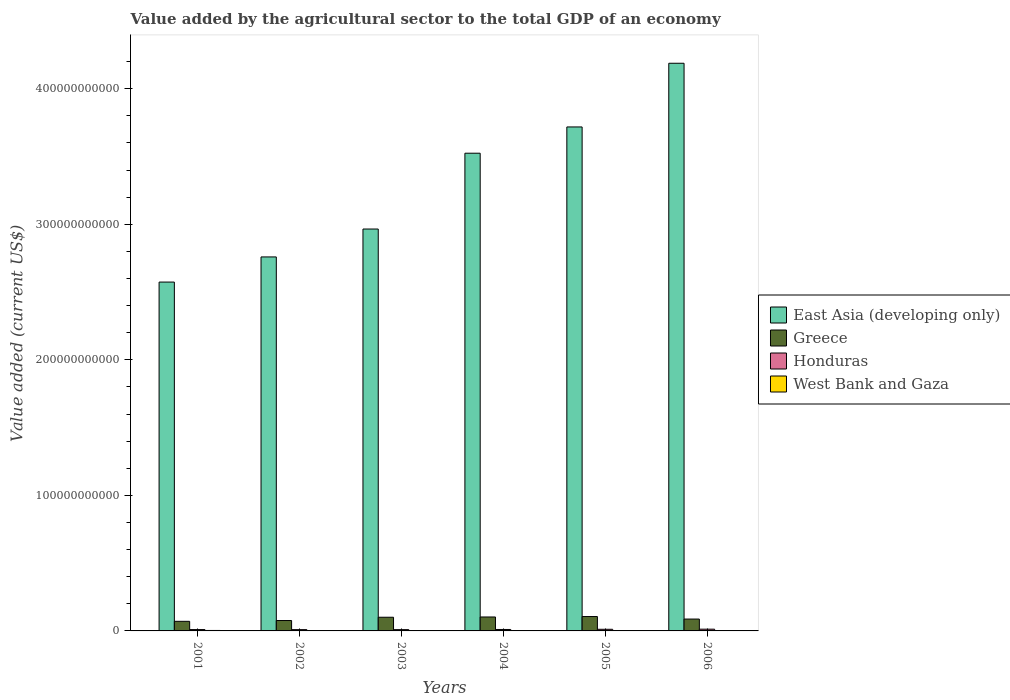How many different coloured bars are there?
Ensure brevity in your answer.  4. Are the number of bars on each tick of the X-axis equal?
Give a very brief answer. Yes. How many bars are there on the 6th tick from the left?
Give a very brief answer. 4. In how many cases, is the number of bars for a given year not equal to the number of legend labels?
Your answer should be very brief. 0. What is the value added by the agricultural sector to the total GDP in West Bank and Gaza in 2003?
Keep it short and to the point. 2.76e+08. Across all years, what is the maximum value added by the agricultural sector to the total GDP in West Bank and Gaza?
Your answer should be compact. 3.40e+08. Across all years, what is the minimum value added by the agricultural sector to the total GDP in Greece?
Give a very brief answer. 7.09e+09. In which year was the value added by the agricultural sector to the total GDP in East Asia (developing only) maximum?
Offer a terse response. 2006. In which year was the value added by the agricultural sector to the total GDP in West Bank and Gaza minimum?
Your answer should be very brief. 2005. What is the total value added by the agricultural sector to the total GDP in West Bank and Gaza in the graph?
Make the answer very short. 1.72e+09. What is the difference between the value added by the agricultural sector to the total GDP in East Asia (developing only) in 2005 and that in 2006?
Give a very brief answer. -4.70e+1. What is the difference between the value added by the agricultural sector to the total GDP in Honduras in 2003 and the value added by the agricultural sector to the total GDP in East Asia (developing only) in 2006?
Give a very brief answer. -4.18e+11. What is the average value added by the agricultural sector to the total GDP in East Asia (developing only) per year?
Keep it short and to the point. 3.29e+11. In the year 2005, what is the difference between the value added by the agricultural sector to the total GDP in Honduras and value added by the agricultural sector to the total GDP in Greece?
Offer a terse response. -9.41e+09. What is the ratio of the value added by the agricultural sector to the total GDP in Greece in 2002 to that in 2003?
Provide a succinct answer. 0.76. Is the value added by the agricultural sector to the total GDP in East Asia (developing only) in 2001 less than that in 2003?
Offer a very short reply. Yes. Is the difference between the value added by the agricultural sector to the total GDP in Honduras in 2002 and 2005 greater than the difference between the value added by the agricultural sector to the total GDP in Greece in 2002 and 2005?
Offer a very short reply. Yes. What is the difference between the highest and the second highest value added by the agricultural sector to the total GDP in East Asia (developing only)?
Provide a short and direct response. 4.70e+1. What is the difference between the highest and the lowest value added by the agricultural sector to the total GDP in West Bank and Gaza?
Provide a short and direct response. 8.61e+07. In how many years, is the value added by the agricultural sector to the total GDP in Greece greater than the average value added by the agricultural sector to the total GDP in Greece taken over all years?
Your answer should be compact. 3. Is it the case that in every year, the sum of the value added by the agricultural sector to the total GDP in West Bank and Gaza and value added by the agricultural sector to the total GDP in East Asia (developing only) is greater than the sum of value added by the agricultural sector to the total GDP in Honduras and value added by the agricultural sector to the total GDP in Greece?
Your response must be concise. Yes. Are all the bars in the graph horizontal?
Ensure brevity in your answer.  No. What is the difference between two consecutive major ticks on the Y-axis?
Offer a very short reply. 1.00e+11. Are the values on the major ticks of Y-axis written in scientific E-notation?
Give a very brief answer. No. Does the graph contain grids?
Provide a succinct answer. No. Where does the legend appear in the graph?
Your response must be concise. Center right. How are the legend labels stacked?
Ensure brevity in your answer.  Vertical. What is the title of the graph?
Ensure brevity in your answer.  Value added by the agricultural sector to the total GDP of an economy. Does "Lesotho" appear as one of the legend labels in the graph?
Offer a very short reply. No. What is the label or title of the X-axis?
Make the answer very short. Years. What is the label or title of the Y-axis?
Provide a succinct answer. Value added (current US$). What is the Value added (current US$) in East Asia (developing only) in 2001?
Make the answer very short. 2.57e+11. What is the Value added (current US$) of Greece in 2001?
Ensure brevity in your answer.  7.09e+09. What is the Value added (current US$) in Honduras in 2001?
Provide a succinct answer. 9.96e+08. What is the Value added (current US$) in West Bank and Gaza in 2001?
Your answer should be very brief. 3.40e+08. What is the Value added (current US$) in East Asia (developing only) in 2002?
Make the answer very short. 2.76e+11. What is the Value added (current US$) in Greece in 2002?
Offer a terse response. 7.67e+09. What is the Value added (current US$) of Honduras in 2002?
Provide a succinct answer. 9.47e+08. What is the Value added (current US$) in West Bank and Gaza in 2002?
Keep it short and to the point. 2.86e+08. What is the Value added (current US$) in East Asia (developing only) in 2003?
Give a very brief answer. 2.97e+11. What is the Value added (current US$) of Greece in 2003?
Provide a short and direct response. 1.01e+1. What is the Value added (current US$) of Honduras in 2003?
Keep it short and to the point. 9.45e+08. What is the Value added (current US$) of West Bank and Gaza in 2003?
Provide a short and direct response. 2.76e+08. What is the Value added (current US$) of East Asia (developing only) in 2004?
Provide a succinct answer. 3.52e+11. What is the Value added (current US$) in Greece in 2004?
Ensure brevity in your answer.  1.03e+1. What is the Value added (current US$) of Honduras in 2004?
Your answer should be very brief. 1.07e+09. What is the Value added (current US$) in West Bank and Gaza in 2004?
Make the answer very short. 3.00e+08. What is the Value added (current US$) of East Asia (developing only) in 2005?
Give a very brief answer. 3.72e+11. What is the Value added (current US$) of Greece in 2005?
Provide a succinct answer. 1.06e+1. What is the Value added (current US$) of Honduras in 2005?
Give a very brief answer. 1.21e+09. What is the Value added (current US$) in West Bank and Gaza in 2005?
Offer a terse response. 2.53e+08. What is the Value added (current US$) in East Asia (developing only) in 2006?
Give a very brief answer. 4.19e+11. What is the Value added (current US$) of Greece in 2006?
Ensure brevity in your answer.  8.75e+09. What is the Value added (current US$) in Honduras in 2006?
Your response must be concise. 1.29e+09. What is the Value added (current US$) of West Bank and Gaza in 2006?
Provide a short and direct response. 2.68e+08. Across all years, what is the maximum Value added (current US$) in East Asia (developing only)?
Your response must be concise. 4.19e+11. Across all years, what is the maximum Value added (current US$) in Greece?
Provide a succinct answer. 1.06e+1. Across all years, what is the maximum Value added (current US$) of Honduras?
Offer a terse response. 1.29e+09. Across all years, what is the maximum Value added (current US$) in West Bank and Gaza?
Offer a very short reply. 3.40e+08. Across all years, what is the minimum Value added (current US$) in East Asia (developing only)?
Provide a succinct answer. 2.57e+11. Across all years, what is the minimum Value added (current US$) of Greece?
Offer a very short reply. 7.09e+09. Across all years, what is the minimum Value added (current US$) in Honduras?
Your answer should be compact. 9.45e+08. Across all years, what is the minimum Value added (current US$) of West Bank and Gaza?
Offer a terse response. 2.53e+08. What is the total Value added (current US$) in East Asia (developing only) in the graph?
Ensure brevity in your answer.  1.97e+12. What is the total Value added (current US$) in Greece in the graph?
Give a very brief answer. 5.45e+1. What is the total Value added (current US$) in Honduras in the graph?
Keep it short and to the point. 6.45e+09. What is the total Value added (current US$) of West Bank and Gaza in the graph?
Ensure brevity in your answer.  1.72e+09. What is the difference between the Value added (current US$) in East Asia (developing only) in 2001 and that in 2002?
Ensure brevity in your answer.  -1.86e+1. What is the difference between the Value added (current US$) of Greece in 2001 and that in 2002?
Provide a short and direct response. -5.86e+08. What is the difference between the Value added (current US$) in Honduras in 2001 and that in 2002?
Your response must be concise. 4.88e+07. What is the difference between the Value added (current US$) of West Bank and Gaza in 2001 and that in 2002?
Ensure brevity in your answer.  5.38e+07. What is the difference between the Value added (current US$) of East Asia (developing only) in 2001 and that in 2003?
Your response must be concise. -3.91e+1. What is the difference between the Value added (current US$) in Greece in 2001 and that in 2003?
Make the answer very short. -3.01e+09. What is the difference between the Value added (current US$) of Honduras in 2001 and that in 2003?
Make the answer very short. 5.08e+07. What is the difference between the Value added (current US$) of West Bank and Gaza in 2001 and that in 2003?
Your response must be concise. 6.32e+07. What is the difference between the Value added (current US$) of East Asia (developing only) in 2001 and that in 2004?
Offer a very short reply. -9.51e+1. What is the difference between the Value added (current US$) in Greece in 2001 and that in 2004?
Your response must be concise. -3.20e+09. What is the difference between the Value added (current US$) of Honduras in 2001 and that in 2004?
Your answer should be compact. -7.14e+07. What is the difference between the Value added (current US$) in West Bank and Gaza in 2001 and that in 2004?
Your response must be concise. 3.97e+07. What is the difference between the Value added (current US$) in East Asia (developing only) in 2001 and that in 2005?
Your response must be concise. -1.14e+11. What is the difference between the Value added (current US$) in Greece in 2001 and that in 2005?
Ensure brevity in your answer.  -3.53e+09. What is the difference between the Value added (current US$) of Honduras in 2001 and that in 2005?
Keep it short and to the point. -2.10e+08. What is the difference between the Value added (current US$) in West Bank and Gaza in 2001 and that in 2005?
Offer a terse response. 8.61e+07. What is the difference between the Value added (current US$) in East Asia (developing only) in 2001 and that in 2006?
Your answer should be very brief. -1.61e+11. What is the difference between the Value added (current US$) in Greece in 2001 and that in 2006?
Offer a terse response. -1.66e+09. What is the difference between the Value added (current US$) of Honduras in 2001 and that in 2006?
Give a very brief answer. -2.89e+08. What is the difference between the Value added (current US$) of West Bank and Gaza in 2001 and that in 2006?
Ensure brevity in your answer.  7.17e+07. What is the difference between the Value added (current US$) of East Asia (developing only) in 2002 and that in 2003?
Ensure brevity in your answer.  -2.06e+1. What is the difference between the Value added (current US$) in Greece in 2002 and that in 2003?
Provide a short and direct response. -2.42e+09. What is the difference between the Value added (current US$) in Honduras in 2002 and that in 2003?
Your response must be concise. 2.02e+06. What is the difference between the Value added (current US$) in West Bank and Gaza in 2002 and that in 2003?
Give a very brief answer. 9.34e+06. What is the difference between the Value added (current US$) of East Asia (developing only) in 2002 and that in 2004?
Offer a terse response. -7.65e+1. What is the difference between the Value added (current US$) of Greece in 2002 and that in 2004?
Provide a succinct answer. -2.61e+09. What is the difference between the Value added (current US$) of Honduras in 2002 and that in 2004?
Keep it short and to the point. -1.20e+08. What is the difference between the Value added (current US$) of West Bank and Gaza in 2002 and that in 2004?
Give a very brief answer. -1.41e+07. What is the difference between the Value added (current US$) in East Asia (developing only) in 2002 and that in 2005?
Ensure brevity in your answer.  -9.59e+1. What is the difference between the Value added (current US$) in Greece in 2002 and that in 2005?
Give a very brief answer. -2.94e+09. What is the difference between the Value added (current US$) in Honduras in 2002 and that in 2005?
Your answer should be very brief. -2.59e+08. What is the difference between the Value added (current US$) of West Bank and Gaza in 2002 and that in 2005?
Offer a terse response. 3.23e+07. What is the difference between the Value added (current US$) of East Asia (developing only) in 2002 and that in 2006?
Your response must be concise. -1.43e+11. What is the difference between the Value added (current US$) of Greece in 2002 and that in 2006?
Make the answer very short. -1.08e+09. What is the difference between the Value added (current US$) of Honduras in 2002 and that in 2006?
Your response must be concise. -3.38e+08. What is the difference between the Value added (current US$) of West Bank and Gaza in 2002 and that in 2006?
Provide a succinct answer. 1.79e+07. What is the difference between the Value added (current US$) of East Asia (developing only) in 2003 and that in 2004?
Provide a short and direct response. -5.59e+1. What is the difference between the Value added (current US$) in Greece in 2003 and that in 2004?
Keep it short and to the point. -1.87e+08. What is the difference between the Value added (current US$) of Honduras in 2003 and that in 2004?
Provide a short and direct response. -1.22e+08. What is the difference between the Value added (current US$) in West Bank and Gaza in 2003 and that in 2004?
Your response must be concise. -2.35e+07. What is the difference between the Value added (current US$) of East Asia (developing only) in 2003 and that in 2005?
Give a very brief answer. -7.53e+1. What is the difference between the Value added (current US$) in Greece in 2003 and that in 2005?
Offer a terse response. -5.20e+08. What is the difference between the Value added (current US$) of Honduras in 2003 and that in 2005?
Offer a very short reply. -2.61e+08. What is the difference between the Value added (current US$) in West Bank and Gaza in 2003 and that in 2005?
Your answer should be compact. 2.30e+07. What is the difference between the Value added (current US$) in East Asia (developing only) in 2003 and that in 2006?
Your response must be concise. -1.22e+11. What is the difference between the Value added (current US$) in Greece in 2003 and that in 2006?
Ensure brevity in your answer.  1.35e+09. What is the difference between the Value added (current US$) in Honduras in 2003 and that in 2006?
Provide a short and direct response. -3.40e+08. What is the difference between the Value added (current US$) of West Bank and Gaza in 2003 and that in 2006?
Offer a terse response. 8.54e+06. What is the difference between the Value added (current US$) in East Asia (developing only) in 2004 and that in 2005?
Your response must be concise. -1.94e+1. What is the difference between the Value added (current US$) in Greece in 2004 and that in 2005?
Ensure brevity in your answer.  -3.32e+08. What is the difference between the Value added (current US$) in Honduras in 2004 and that in 2005?
Provide a short and direct response. -1.39e+08. What is the difference between the Value added (current US$) of West Bank and Gaza in 2004 and that in 2005?
Ensure brevity in your answer.  4.64e+07. What is the difference between the Value added (current US$) of East Asia (developing only) in 2004 and that in 2006?
Offer a very short reply. -6.64e+1. What is the difference between the Value added (current US$) of Greece in 2004 and that in 2006?
Your answer should be very brief. 1.53e+09. What is the difference between the Value added (current US$) of Honduras in 2004 and that in 2006?
Provide a succinct answer. -2.18e+08. What is the difference between the Value added (current US$) in West Bank and Gaza in 2004 and that in 2006?
Offer a terse response. 3.20e+07. What is the difference between the Value added (current US$) in East Asia (developing only) in 2005 and that in 2006?
Offer a terse response. -4.70e+1. What is the difference between the Value added (current US$) in Greece in 2005 and that in 2006?
Your answer should be very brief. 1.87e+09. What is the difference between the Value added (current US$) in Honduras in 2005 and that in 2006?
Your answer should be very brief. -7.93e+07. What is the difference between the Value added (current US$) of West Bank and Gaza in 2005 and that in 2006?
Keep it short and to the point. -1.44e+07. What is the difference between the Value added (current US$) of East Asia (developing only) in 2001 and the Value added (current US$) of Greece in 2002?
Offer a very short reply. 2.50e+11. What is the difference between the Value added (current US$) of East Asia (developing only) in 2001 and the Value added (current US$) of Honduras in 2002?
Make the answer very short. 2.56e+11. What is the difference between the Value added (current US$) of East Asia (developing only) in 2001 and the Value added (current US$) of West Bank and Gaza in 2002?
Your response must be concise. 2.57e+11. What is the difference between the Value added (current US$) of Greece in 2001 and the Value added (current US$) of Honduras in 2002?
Your answer should be very brief. 6.14e+09. What is the difference between the Value added (current US$) of Greece in 2001 and the Value added (current US$) of West Bank and Gaza in 2002?
Offer a terse response. 6.80e+09. What is the difference between the Value added (current US$) of Honduras in 2001 and the Value added (current US$) of West Bank and Gaza in 2002?
Provide a short and direct response. 7.10e+08. What is the difference between the Value added (current US$) of East Asia (developing only) in 2001 and the Value added (current US$) of Greece in 2003?
Your response must be concise. 2.47e+11. What is the difference between the Value added (current US$) in East Asia (developing only) in 2001 and the Value added (current US$) in Honduras in 2003?
Your answer should be compact. 2.56e+11. What is the difference between the Value added (current US$) of East Asia (developing only) in 2001 and the Value added (current US$) of West Bank and Gaza in 2003?
Make the answer very short. 2.57e+11. What is the difference between the Value added (current US$) of Greece in 2001 and the Value added (current US$) of Honduras in 2003?
Make the answer very short. 6.14e+09. What is the difference between the Value added (current US$) of Greece in 2001 and the Value added (current US$) of West Bank and Gaza in 2003?
Provide a short and direct response. 6.81e+09. What is the difference between the Value added (current US$) in Honduras in 2001 and the Value added (current US$) in West Bank and Gaza in 2003?
Provide a short and direct response. 7.20e+08. What is the difference between the Value added (current US$) of East Asia (developing only) in 2001 and the Value added (current US$) of Greece in 2004?
Make the answer very short. 2.47e+11. What is the difference between the Value added (current US$) in East Asia (developing only) in 2001 and the Value added (current US$) in Honduras in 2004?
Your answer should be compact. 2.56e+11. What is the difference between the Value added (current US$) in East Asia (developing only) in 2001 and the Value added (current US$) in West Bank and Gaza in 2004?
Make the answer very short. 2.57e+11. What is the difference between the Value added (current US$) of Greece in 2001 and the Value added (current US$) of Honduras in 2004?
Provide a short and direct response. 6.02e+09. What is the difference between the Value added (current US$) of Greece in 2001 and the Value added (current US$) of West Bank and Gaza in 2004?
Ensure brevity in your answer.  6.79e+09. What is the difference between the Value added (current US$) of Honduras in 2001 and the Value added (current US$) of West Bank and Gaza in 2004?
Offer a terse response. 6.96e+08. What is the difference between the Value added (current US$) in East Asia (developing only) in 2001 and the Value added (current US$) in Greece in 2005?
Make the answer very short. 2.47e+11. What is the difference between the Value added (current US$) in East Asia (developing only) in 2001 and the Value added (current US$) in Honduras in 2005?
Offer a very short reply. 2.56e+11. What is the difference between the Value added (current US$) in East Asia (developing only) in 2001 and the Value added (current US$) in West Bank and Gaza in 2005?
Keep it short and to the point. 2.57e+11. What is the difference between the Value added (current US$) in Greece in 2001 and the Value added (current US$) in Honduras in 2005?
Offer a very short reply. 5.88e+09. What is the difference between the Value added (current US$) in Greece in 2001 and the Value added (current US$) in West Bank and Gaza in 2005?
Your response must be concise. 6.83e+09. What is the difference between the Value added (current US$) of Honduras in 2001 and the Value added (current US$) of West Bank and Gaza in 2005?
Offer a terse response. 7.43e+08. What is the difference between the Value added (current US$) of East Asia (developing only) in 2001 and the Value added (current US$) of Greece in 2006?
Ensure brevity in your answer.  2.49e+11. What is the difference between the Value added (current US$) of East Asia (developing only) in 2001 and the Value added (current US$) of Honduras in 2006?
Provide a succinct answer. 2.56e+11. What is the difference between the Value added (current US$) in East Asia (developing only) in 2001 and the Value added (current US$) in West Bank and Gaza in 2006?
Provide a short and direct response. 2.57e+11. What is the difference between the Value added (current US$) in Greece in 2001 and the Value added (current US$) in Honduras in 2006?
Your answer should be compact. 5.80e+09. What is the difference between the Value added (current US$) in Greece in 2001 and the Value added (current US$) in West Bank and Gaza in 2006?
Provide a succinct answer. 6.82e+09. What is the difference between the Value added (current US$) in Honduras in 2001 and the Value added (current US$) in West Bank and Gaza in 2006?
Ensure brevity in your answer.  7.28e+08. What is the difference between the Value added (current US$) of East Asia (developing only) in 2002 and the Value added (current US$) of Greece in 2003?
Keep it short and to the point. 2.66e+11. What is the difference between the Value added (current US$) in East Asia (developing only) in 2002 and the Value added (current US$) in Honduras in 2003?
Your response must be concise. 2.75e+11. What is the difference between the Value added (current US$) of East Asia (developing only) in 2002 and the Value added (current US$) of West Bank and Gaza in 2003?
Your answer should be compact. 2.76e+11. What is the difference between the Value added (current US$) in Greece in 2002 and the Value added (current US$) in Honduras in 2003?
Make the answer very short. 6.73e+09. What is the difference between the Value added (current US$) of Greece in 2002 and the Value added (current US$) of West Bank and Gaza in 2003?
Provide a succinct answer. 7.40e+09. What is the difference between the Value added (current US$) in Honduras in 2002 and the Value added (current US$) in West Bank and Gaza in 2003?
Your answer should be compact. 6.71e+08. What is the difference between the Value added (current US$) of East Asia (developing only) in 2002 and the Value added (current US$) of Greece in 2004?
Make the answer very short. 2.66e+11. What is the difference between the Value added (current US$) in East Asia (developing only) in 2002 and the Value added (current US$) in Honduras in 2004?
Offer a terse response. 2.75e+11. What is the difference between the Value added (current US$) of East Asia (developing only) in 2002 and the Value added (current US$) of West Bank and Gaza in 2004?
Provide a succinct answer. 2.76e+11. What is the difference between the Value added (current US$) of Greece in 2002 and the Value added (current US$) of Honduras in 2004?
Provide a succinct answer. 6.60e+09. What is the difference between the Value added (current US$) in Greece in 2002 and the Value added (current US$) in West Bank and Gaza in 2004?
Offer a terse response. 7.37e+09. What is the difference between the Value added (current US$) in Honduras in 2002 and the Value added (current US$) in West Bank and Gaza in 2004?
Your response must be concise. 6.48e+08. What is the difference between the Value added (current US$) of East Asia (developing only) in 2002 and the Value added (current US$) of Greece in 2005?
Make the answer very short. 2.65e+11. What is the difference between the Value added (current US$) in East Asia (developing only) in 2002 and the Value added (current US$) in Honduras in 2005?
Offer a very short reply. 2.75e+11. What is the difference between the Value added (current US$) of East Asia (developing only) in 2002 and the Value added (current US$) of West Bank and Gaza in 2005?
Provide a succinct answer. 2.76e+11. What is the difference between the Value added (current US$) of Greece in 2002 and the Value added (current US$) of Honduras in 2005?
Offer a very short reply. 6.47e+09. What is the difference between the Value added (current US$) in Greece in 2002 and the Value added (current US$) in West Bank and Gaza in 2005?
Keep it short and to the point. 7.42e+09. What is the difference between the Value added (current US$) in Honduras in 2002 and the Value added (current US$) in West Bank and Gaza in 2005?
Your response must be concise. 6.94e+08. What is the difference between the Value added (current US$) of East Asia (developing only) in 2002 and the Value added (current US$) of Greece in 2006?
Offer a very short reply. 2.67e+11. What is the difference between the Value added (current US$) in East Asia (developing only) in 2002 and the Value added (current US$) in Honduras in 2006?
Your answer should be compact. 2.75e+11. What is the difference between the Value added (current US$) in East Asia (developing only) in 2002 and the Value added (current US$) in West Bank and Gaza in 2006?
Give a very brief answer. 2.76e+11. What is the difference between the Value added (current US$) in Greece in 2002 and the Value added (current US$) in Honduras in 2006?
Make the answer very short. 6.39e+09. What is the difference between the Value added (current US$) of Greece in 2002 and the Value added (current US$) of West Bank and Gaza in 2006?
Provide a succinct answer. 7.40e+09. What is the difference between the Value added (current US$) in Honduras in 2002 and the Value added (current US$) in West Bank and Gaza in 2006?
Provide a short and direct response. 6.80e+08. What is the difference between the Value added (current US$) of East Asia (developing only) in 2003 and the Value added (current US$) of Greece in 2004?
Make the answer very short. 2.86e+11. What is the difference between the Value added (current US$) of East Asia (developing only) in 2003 and the Value added (current US$) of Honduras in 2004?
Give a very brief answer. 2.95e+11. What is the difference between the Value added (current US$) of East Asia (developing only) in 2003 and the Value added (current US$) of West Bank and Gaza in 2004?
Give a very brief answer. 2.96e+11. What is the difference between the Value added (current US$) of Greece in 2003 and the Value added (current US$) of Honduras in 2004?
Your response must be concise. 9.03e+09. What is the difference between the Value added (current US$) in Greece in 2003 and the Value added (current US$) in West Bank and Gaza in 2004?
Keep it short and to the point. 9.80e+09. What is the difference between the Value added (current US$) of Honduras in 2003 and the Value added (current US$) of West Bank and Gaza in 2004?
Your answer should be compact. 6.46e+08. What is the difference between the Value added (current US$) of East Asia (developing only) in 2003 and the Value added (current US$) of Greece in 2005?
Your response must be concise. 2.86e+11. What is the difference between the Value added (current US$) of East Asia (developing only) in 2003 and the Value added (current US$) of Honduras in 2005?
Your answer should be compact. 2.95e+11. What is the difference between the Value added (current US$) of East Asia (developing only) in 2003 and the Value added (current US$) of West Bank and Gaza in 2005?
Give a very brief answer. 2.96e+11. What is the difference between the Value added (current US$) of Greece in 2003 and the Value added (current US$) of Honduras in 2005?
Give a very brief answer. 8.89e+09. What is the difference between the Value added (current US$) in Greece in 2003 and the Value added (current US$) in West Bank and Gaza in 2005?
Give a very brief answer. 9.84e+09. What is the difference between the Value added (current US$) of Honduras in 2003 and the Value added (current US$) of West Bank and Gaza in 2005?
Offer a terse response. 6.92e+08. What is the difference between the Value added (current US$) in East Asia (developing only) in 2003 and the Value added (current US$) in Greece in 2006?
Provide a short and direct response. 2.88e+11. What is the difference between the Value added (current US$) of East Asia (developing only) in 2003 and the Value added (current US$) of Honduras in 2006?
Give a very brief answer. 2.95e+11. What is the difference between the Value added (current US$) of East Asia (developing only) in 2003 and the Value added (current US$) of West Bank and Gaza in 2006?
Keep it short and to the point. 2.96e+11. What is the difference between the Value added (current US$) of Greece in 2003 and the Value added (current US$) of Honduras in 2006?
Ensure brevity in your answer.  8.81e+09. What is the difference between the Value added (current US$) of Greece in 2003 and the Value added (current US$) of West Bank and Gaza in 2006?
Offer a terse response. 9.83e+09. What is the difference between the Value added (current US$) of Honduras in 2003 and the Value added (current US$) of West Bank and Gaza in 2006?
Ensure brevity in your answer.  6.78e+08. What is the difference between the Value added (current US$) of East Asia (developing only) in 2004 and the Value added (current US$) of Greece in 2005?
Ensure brevity in your answer.  3.42e+11. What is the difference between the Value added (current US$) in East Asia (developing only) in 2004 and the Value added (current US$) in Honduras in 2005?
Provide a short and direct response. 3.51e+11. What is the difference between the Value added (current US$) in East Asia (developing only) in 2004 and the Value added (current US$) in West Bank and Gaza in 2005?
Make the answer very short. 3.52e+11. What is the difference between the Value added (current US$) in Greece in 2004 and the Value added (current US$) in Honduras in 2005?
Your answer should be very brief. 9.08e+09. What is the difference between the Value added (current US$) in Greece in 2004 and the Value added (current US$) in West Bank and Gaza in 2005?
Your response must be concise. 1.00e+1. What is the difference between the Value added (current US$) in Honduras in 2004 and the Value added (current US$) in West Bank and Gaza in 2005?
Ensure brevity in your answer.  8.14e+08. What is the difference between the Value added (current US$) in East Asia (developing only) in 2004 and the Value added (current US$) in Greece in 2006?
Provide a short and direct response. 3.44e+11. What is the difference between the Value added (current US$) in East Asia (developing only) in 2004 and the Value added (current US$) in Honduras in 2006?
Keep it short and to the point. 3.51e+11. What is the difference between the Value added (current US$) of East Asia (developing only) in 2004 and the Value added (current US$) of West Bank and Gaza in 2006?
Your response must be concise. 3.52e+11. What is the difference between the Value added (current US$) of Greece in 2004 and the Value added (current US$) of Honduras in 2006?
Offer a terse response. 9.00e+09. What is the difference between the Value added (current US$) in Greece in 2004 and the Value added (current US$) in West Bank and Gaza in 2006?
Provide a succinct answer. 1.00e+1. What is the difference between the Value added (current US$) in Honduras in 2004 and the Value added (current US$) in West Bank and Gaza in 2006?
Your answer should be compact. 8.00e+08. What is the difference between the Value added (current US$) in East Asia (developing only) in 2005 and the Value added (current US$) in Greece in 2006?
Your answer should be compact. 3.63e+11. What is the difference between the Value added (current US$) in East Asia (developing only) in 2005 and the Value added (current US$) in Honduras in 2006?
Give a very brief answer. 3.71e+11. What is the difference between the Value added (current US$) in East Asia (developing only) in 2005 and the Value added (current US$) in West Bank and Gaza in 2006?
Keep it short and to the point. 3.72e+11. What is the difference between the Value added (current US$) of Greece in 2005 and the Value added (current US$) of Honduras in 2006?
Give a very brief answer. 9.33e+09. What is the difference between the Value added (current US$) of Greece in 2005 and the Value added (current US$) of West Bank and Gaza in 2006?
Your answer should be very brief. 1.03e+1. What is the difference between the Value added (current US$) of Honduras in 2005 and the Value added (current US$) of West Bank and Gaza in 2006?
Provide a succinct answer. 9.38e+08. What is the average Value added (current US$) of East Asia (developing only) per year?
Your answer should be compact. 3.29e+11. What is the average Value added (current US$) in Greece per year?
Provide a short and direct response. 9.08e+09. What is the average Value added (current US$) of Honduras per year?
Offer a terse response. 1.07e+09. What is the average Value added (current US$) in West Bank and Gaza per year?
Provide a short and direct response. 2.87e+08. In the year 2001, what is the difference between the Value added (current US$) in East Asia (developing only) and Value added (current US$) in Greece?
Your answer should be very brief. 2.50e+11. In the year 2001, what is the difference between the Value added (current US$) of East Asia (developing only) and Value added (current US$) of Honduras?
Provide a short and direct response. 2.56e+11. In the year 2001, what is the difference between the Value added (current US$) in East Asia (developing only) and Value added (current US$) in West Bank and Gaza?
Offer a terse response. 2.57e+11. In the year 2001, what is the difference between the Value added (current US$) in Greece and Value added (current US$) in Honduras?
Provide a short and direct response. 6.09e+09. In the year 2001, what is the difference between the Value added (current US$) of Greece and Value added (current US$) of West Bank and Gaza?
Ensure brevity in your answer.  6.75e+09. In the year 2001, what is the difference between the Value added (current US$) of Honduras and Value added (current US$) of West Bank and Gaza?
Provide a succinct answer. 6.57e+08. In the year 2002, what is the difference between the Value added (current US$) in East Asia (developing only) and Value added (current US$) in Greece?
Keep it short and to the point. 2.68e+11. In the year 2002, what is the difference between the Value added (current US$) of East Asia (developing only) and Value added (current US$) of Honduras?
Provide a short and direct response. 2.75e+11. In the year 2002, what is the difference between the Value added (current US$) in East Asia (developing only) and Value added (current US$) in West Bank and Gaza?
Ensure brevity in your answer.  2.76e+11. In the year 2002, what is the difference between the Value added (current US$) of Greece and Value added (current US$) of Honduras?
Offer a very short reply. 6.72e+09. In the year 2002, what is the difference between the Value added (current US$) of Greece and Value added (current US$) of West Bank and Gaza?
Offer a very short reply. 7.39e+09. In the year 2002, what is the difference between the Value added (current US$) in Honduras and Value added (current US$) in West Bank and Gaza?
Keep it short and to the point. 6.62e+08. In the year 2003, what is the difference between the Value added (current US$) of East Asia (developing only) and Value added (current US$) of Greece?
Keep it short and to the point. 2.86e+11. In the year 2003, what is the difference between the Value added (current US$) of East Asia (developing only) and Value added (current US$) of Honduras?
Your answer should be compact. 2.96e+11. In the year 2003, what is the difference between the Value added (current US$) of East Asia (developing only) and Value added (current US$) of West Bank and Gaza?
Give a very brief answer. 2.96e+11. In the year 2003, what is the difference between the Value added (current US$) of Greece and Value added (current US$) of Honduras?
Provide a short and direct response. 9.15e+09. In the year 2003, what is the difference between the Value added (current US$) of Greece and Value added (current US$) of West Bank and Gaza?
Your response must be concise. 9.82e+09. In the year 2003, what is the difference between the Value added (current US$) of Honduras and Value added (current US$) of West Bank and Gaza?
Provide a succinct answer. 6.69e+08. In the year 2004, what is the difference between the Value added (current US$) of East Asia (developing only) and Value added (current US$) of Greece?
Your answer should be compact. 3.42e+11. In the year 2004, what is the difference between the Value added (current US$) of East Asia (developing only) and Value added (current US$) of Honduras?
Offer a terse response. 3.51e+11. In the year 2004, what is the difference between the Value added (current US$) of East Asia (developing only) and Value added (current US$) of West Bank and Gaza?
Offer a very short reply. 3.52e+11. In the year 2004, what is the difference between the Value added (current US$) of Greece and Value added (current US$) of Honduras?
Give a very brief answer. 9.22e+09. In the year 2004, what is the difference between the Value added (current US$) of Greece and Value added (current US$) of West Bank and Gaza?
Keep it short and to the point. 9.98e+09. In the year 2004, what is the difference between the Value added (current US$) of Honduras and Value added (current US$) of West Bank and Gaza?
Your answer should be compact. 7.68e+08. In the year 2005, what is the difference between the Value added (current US$) in East Asia (developing only) and Value added (current US$) in Greece?
Your response must be concise. 3.61e+11. In the year 2005, what is the difference between the Value added (current US$) in East Asia (developing only) and Value added (current US$) in Honduras?
Ensure brevity in your answer.  3.71e+11. In the year 2005, what is the difference between the Value added (current US$) in East Asia (developing only) and Value added (current US$) in West Bank and Gaza?
Ensure brevity in your answer.  3.72e+11. In the year 2005, what is the difference between the Value added (current US$) of Greece and Value added (current US$) of Honduras?
Make the answer very short. 9.41e+09. In the year 2005, what is the difference between the Value added (current US$) in Greece and Value added (current US$) in West Bank and Gaza?
Keep it short and to the point. 1.04e+1. In the year 2005, what is the difference between the Value added (current US$) of Honduras and Value added (current US$) of West Bank and Gaza?
Provide a short and direct response. 9.53e+08. In the year 2006, what is the difference between the Value added (current US$) of East Asia (developing only) and Value added (current US$) of Greece?
Give a very brief answer. 4.10e+11. In the year 2006, what is the difference between the Value added (current US$) of East Asia (developing only) and Value added (current US$) of Honduras?
Offer a very short reply. 4.18e+11. In the year 2006, what is the difference between the Value added (current US$) in East Asia (developing only) and Value added (current US$) in West Bank and Gaza?
Offer a very short reply. 4.19e+11. In the year 2006, what is the difference between the Value added (current US$) of Greece and Value added (current US$) of Honduras?
Make the answer very short. 7.46e+09. In the year 2006, what is the difference between the Value added (current US$) of Greece and Value added (current US$) of West Bank and Gaza?
Your response must be concise. 8.48e+09. In the year 2006, what is the difference between the Value added (current US$) of Honduras and Value added (current US$) of West Bank and Gaza?
Ensure brevity in your answer.  1.02e+09. What is the ratio of the Value added (current US$) in East Asia (developing only) in 2001 to that in 2002?
Your answer should be very brief. 0.93. What is the ratio of the Value added (current US$) of Greece in 2001 to that in 2002?
Offer a very short reply. 0.92. What is the ratio of the Value added (current US$) in Honduras in 2001 to that in 2002?
Your answer should be very brief. 1.05. What is the ratio of the Value added (current US$) of West Bank and Gaza in 2001 to that in 2002?
Your answer should be very brief. 1.19. What is the ratio of the Value added (current US$) in East Asia (developing only) in 2001 to that in 2003?
Keep it short and to the point. 0.87. What is the ratio of the Value added (current US$) in Greece in 2001 to that in 2003?
Provide a short and direct response. 0.7. What is the ratio of the Value added (current US$) of Honduras in 2001 to that in 2003?
Keep it short and to the point. 1.05. What is the ratio of the Value added (current US$) of West Bank and Gaza in 2001 to that in 2003?
Provide a short and direct response. 1.23. What is the ratio of the Value added (current US$) in East Asia (developing only) in 2001 to that in 2004?
Your answer should be compact. 0.73. What is the ratio of the Value added (current US$) of Greece in 2001 to that in 2004?
Your response must be concise. 0.69. What is the ratio of the Value added (current US$) in Honduras in 2001 to that in 2004?
Make the answer very short. 0.93. What is the ratio of the Value added (current US$) in West Bank and Gaza in 2001 to that in 2004?
Your answer should be very brief. 1.13. What is the ratio of the Value added (current US$) of East Asia (developing only) in 2001 to that in 2005?
Provide a short and direct response. 0.69. What is the ratio of the Value added (current US$) in Greece in 2001 to that in 2005?
Your response must be concise. 0.67. What is the ratio of the Value added (current US$) in Honduras in 2001 to that in 2005?
Make the answer very short. 0.83. What is the ratio of the Value added (current US$) of West Bank and Gaza in 2001 to that in 2005?
Your answer should be very brief. 1.34. What is the ratio of the Value added (current US$) of East Asia (developing only) in 2001 to that in 2006?
Make the answer very short. 0.61. What is the ratio of the Value added (current US$) in Greece in 2001 to that in 2006?
Provide a succinct answer. 0.81. What is the ratio of the Value added (current US$) of Honduras in 2001 to that in 2006?
Your response must be concise. 0.78. What is the ratio of the Value added (current US$) in West Bank and Gaza in 2001 to that in 2006?
Your response must be concise. 1.27. What is the ratio of the Value added (current US$) of East Asia (developing only) in 2002 to that in 2003?
Keep it short and to the point. 0.93. What is the ratio of the Value added (current US$) in Greece in 2002 to that in 2003?
Your answer should be compact. 0.76. What is the ratio of the Value added (current US$) of Honduras in 2002 to that in 2003?
Your response must be concise. 1. What is the ratio of the Value added (current US$) in West Bank and Gaza in 2002 to that in 2003?
Provide a short and direct response. 1.03. What is the ratio of the Value added (current US$) in East Asia (developing only) in 2002 to that in 2004?
Provide a short and direct response. 0.78. What is the ratio of the Value added (current US$) of Greece in 2002 to that in 2004?
Provide a succinct answer. 0.75. What is the ratio of the Value added (current US$) in Honduras in 2002 to that in 2004?
Offer a terse response. 0.89. What is the ratio of the Value added (current US$) in West Bank and Gaza in 2002 to that in 2004?
Provide a succinct answer. 0.95. What is the ratio of the Value added (current US$) in East Asia (developing only) in 2002 to that in 2005?
Your response must be concise. 0.74. What is the ratio of the Value added (current US$) in Greece in 2002 to that in 2005?
Your response must be concise. 0.72. What is the ratio of the Value added (current US$) of Honduras in 2002 to that in 2005?
Provide a short and direct response. 0.79. What is the ratio of the Value added (current US$) in West Bank and Gaza in 2002 to that in 2005?
Your answer should be very brief. 1.13. What is the ratio of the Value added (current US$) of East Asia (developing only) in 2002 to that in 2006?
Provide a succinct answer. 0.66. What is the ratio of the Value added (current US$) in Greece in 2002 to that in 2006?
Your response must be concise. 0.88. What is the ratio of the Value added (current US$) in Honduras in 2002 to that in 2006?
Offer a terse response. 0.74. What is the ratio of the Value added (current US$) in West Bank and Gaza in 2002 to that in 2006?
Offer a terse response. 1.07. What is the ratio of the Value added (current US$) of East Asia (developing only) in 2003 to that in 2004?
Make the answer very short. 0.84. What is the ratio of the Value added (current US$) in Greece in 2003 to that in 2004?
Your answer should be compact. 0.98. What is the ratio of the Value added (current US$) of Honduras in 2003 to that in 2004?
Your answer should be very brief. 0.89. What is the ratio of the Value added (current US$) of West Bank and Gaza in 2003 to that in 2004?
Give a very brief answer. 0.92. What is the ratio of the Value added (current US$) in East Asia (developing only) in 2003 to that in 2005?
Your answer should be compact. 0.8. What is the ratio of the Value added (current US$) of Greece in 2003 to that in 2005?
Give a very brief answer. 0.95. What is the ratio of the Value added (current US$) of Honduras in 2003 to that in 2005?
Your response must be concise. 0.78. What is the ratio of the Value added (current US$) of West Bank and Gaza in 2003 to that in 2005?
Your answer should be very brief. 1.09. What is the ratio of the Value added (current US$) of East Asia (developing only) in 2003 to that in 2006?
Your answer should be very brief. 0.71. What is the ratio of the Value added (current US$) of Greece in 2003 to that in 2006?
Ensure brevity in your answer.  1.15. What is the ratio of the Value added (current US$) of Honduras in 2003 to that in 2006?
Provide a short and direct response. 0.74. What is the ratio of the Value added (current US$) in West Bank and Gaza in 2003 to that in 2006?
Your response must be concise. 1.03. What is the ratio of the Value added (current US$) of East Asia (developing only) in 2004 to that in 2005?
Keep it short and to the point. 0.95. What is the ratio of the Value added (current US$) of Greece in 2004 to that in 2005?
Give a very brief answer. 0.97. What is the ratio of the Value added (current US$) in Honduras in 2004 to that in 2005?
Ensure brevity in your answer.  0.89. What is the ratio of the Value added (current US$) of West Bank and Gaza in 2004 to that in 2005?
Offer a very short reply. 1.18. What is the ratio of the Value added (current US$) of East Asia (developing only) in 2004 to that in 2006?
Your answer should be very brief. 0.84. What is the ratio of the Value added (current US$) of Greece in 2004 to that in 2006?
Give a very brief answer. 1.18. What is the ratio of the Value added (current US$) in Honduras in 2004 to that in 2006?
Your answer should be very brief. 0.83. What is the ratio of the Value added (current US$) of West Bank and Gaza in 2004 to that in 2006?
Ensure brevity in your answer.  1.12. What is the ratio of the Value added (current US$) of East Asia (developing only) in 2005 to that in 2006?
Ensure brevity in your answer.  0.89. What is the ratio of the Value added (current US$) in Greece in 2005 to that in 2006?
Provide a short and direct response. 1.21. What is the ratio of the Value added (current US$) of Honduras in 2005 to that in 2006?
Keep it short and to the point. 0.94. What is the ratio of the Value added (current US$) of West Bank and Gaza in 2005 to that in 2006?
Your response must be concise. 0.95. What is the difference between the highest and the second highest Value added (current US$) in East Asia (developing only)?
Provide a short and direct response. 4.70e+1. What is the difference between the highest and the second highest Value added (current US$) of Greece?
Offer a very short reply. 3.32e+08. What is the difference between the highest and the second highest Value added (current US$) of Honduras?
Your answer should be compact. 7.93e+07. What is the difference between the highest and the second highest Value added (current US$) in West Bank and Gaza?
Give a very brief answer. 3.97e+07. What is the difference between the highest and the lowest Value added (current US$) in East Asia (developing only)?
Your response must be concise. 1.61e+11. What is the difference between the highest and the lowest Value added (current US$) in Greece?
Offer a very short reply. 3.53e+09. What is the difference between the highest and the lowest Value added (current US$) in Honduras?
Keep it short and to the point. 3.40e+08. What is the difference between the highest and the lowest Value added (current US$) of West Bank and Gaza?
Your answer should be very brief. 8.61e+07. 